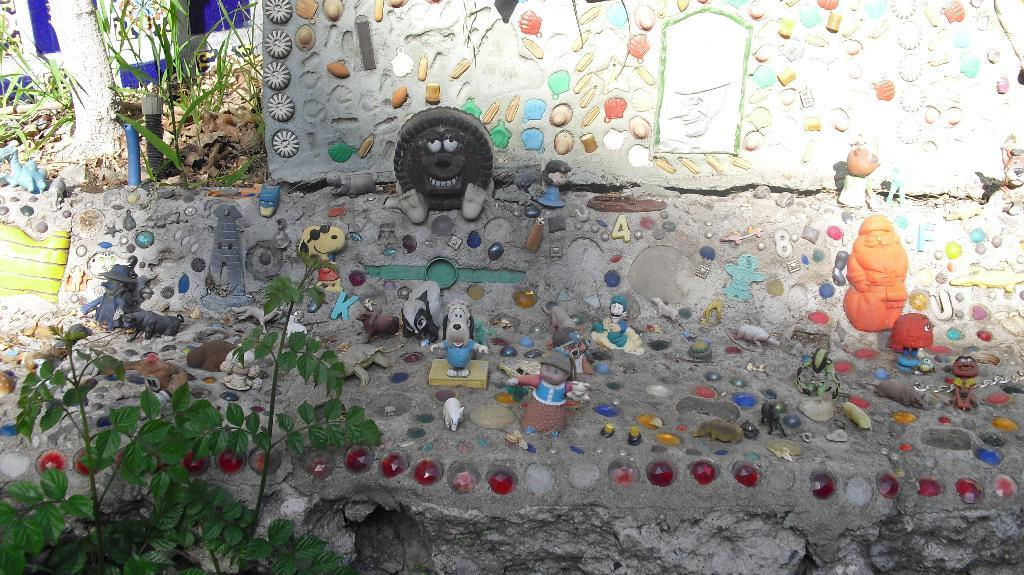What is attached to the cement wall in the image? Pebbles and toys are attached to the cement wall in the image. Where is the plant located in the image? The plant is in the left bottom of the image. What type of vegetation is visible in the left top of the image? There is grass in the left top of the image. Can you tell me how many plantations are visible in the image? There are no plantations present in the image. Is your aunt visible in the image? There is no mention of an aunt in the provided facts, and therefore no such person can be identified in the image. 